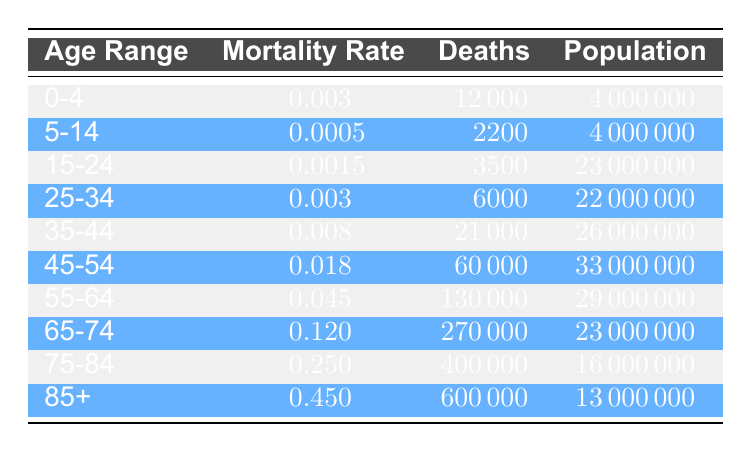What is the mortality rate for the age group 45-54? You can find the mortality rate for the age group 45-54 directly in the table under the "Mortality Rate" column corresponding to that age range. It is listed as 0.018.
Answer: 0.018 How many deaths occurred in the age group 85+? The number of deaths for the age group 85+ can be located in the "Deaths" column in the row for that age range. It is recorded as 600000.
Answer: 600000 What is the total population for all age groups listed? To find the total population, sum the population of each age group in the "Population" column. The populations are 4000000, 4000000, 23000000, 22000000, 26000000, 33000000, 29000000, 23000000, 16000000, and 13000000. Adding these yields a total population of 134000000.
Answer: 134000000 Is the mortality rate for the age group 75-84 greater than that of the age group 65-74? Compare the mortality rates in the "Mortality Rate" column for both age groups. The rate for 75-84 is 0.25 and for 65-74 is 0.12. Since 0.25 is greater than 0.12, the statement is true.
Answer: Yes What is the average mortality rate of age groups 0-4, 5-14, and 15-24? First, find the mortality rates for these age groups: 0-4 is 0.003, 5-14 is 0.0005, and 15-24 is 0.0015. Next, sum these rates: 0.003 + 0.0005 + 0.0015 = 0.005. Finally, divide by the number of age groups (3) to get the average: 0.005 / 3 = 0.00167.
Answer: 0.00167 How many deaths were there for age groups 55-64 and 65-74 combined? Locate the numbers of deaths in the "Deaths" column for both age groups. For 55-64 it is 130000 and for 65-74 it is 270000. The combined total is 130000 + 270000 = 400000.
Answer: 400000 What is the mortality rate for the age group 25-34 relative to the highest mortality rate? The mortality rate for 25-34 is 0.003. The highest mortality rate is found in the age group 85+ which is 0.45. To determine the relative mortality rate, divide 0.003 by 0.45 to gain an understanding of how it compares to the highest rate: 0.003 / 0.45 = 0.00667 or 0.67%.
Answer: 0.67% Is the population of the age group 35-44 larger than that of the age group 45-54? Compare the population figures in the "Population" column for both age groups. The population for 35-44 is 26000000, while for 45-54 it is 33000000. Since 26000000 is less than 33000000, the statement is false.
Answer: No 